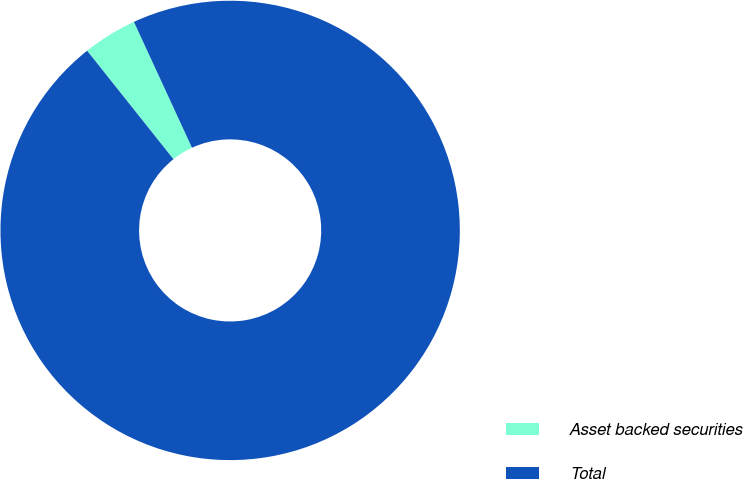Convert chart to OTSL. <chart><loc_0><loc_0><loc_500><loc_500><pie_chart><fcel>Asset backed securities<fcel>Total<nl><fcel>3.82%<fcel>96.18%<nl></chart> 